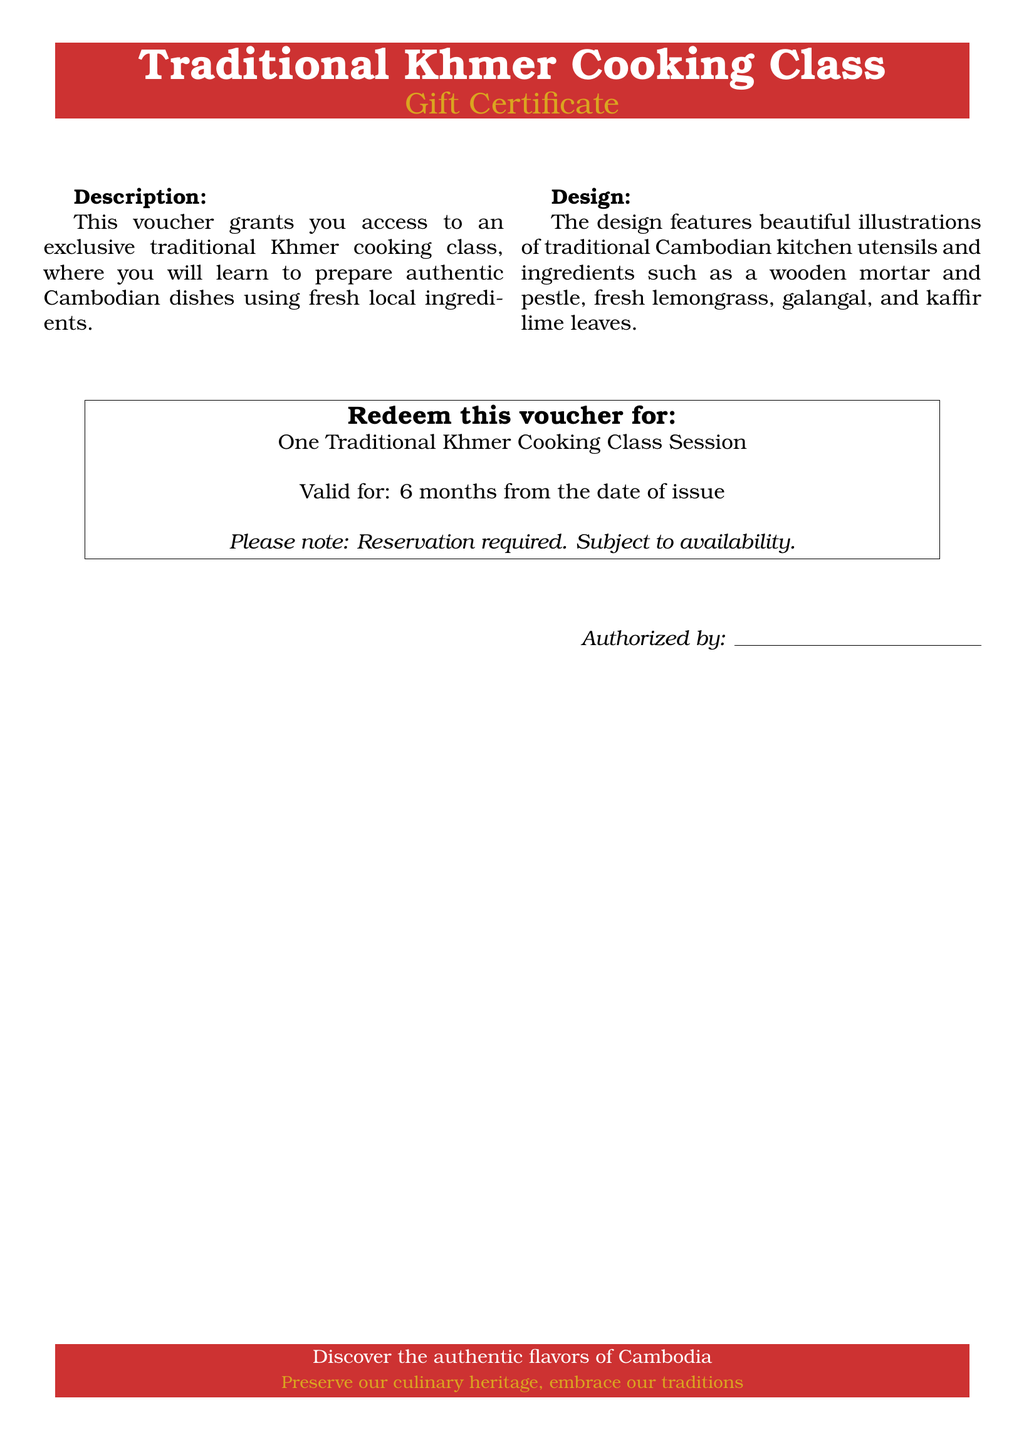What is the title of the voucher? The title is prominently displayed at the top of the voucher, which indicates the primary service being offered.
Answer: Traditional Khmer Cooking Class What is the validity period for the voucher? The validity period is stated in the section concerning the redemption of the voucher.
Answer: 6 months What must participants do to use the voucher? The document provides a requirement that must be fulfilled to redeem the voucher for the cooking class.
Answer: Reservation required What type of sessions does this voucher cover? The type of session is specified in the redemption section, indicating what the recipient will experience.
Answer: One Traditional Khmer Cooking Class Session What design elements are featured on the voucher? The design elements include illustrations mentioned in the design description, showcasing the cultural aspect of the voucher.
Answer: Traditional Cambodian kitchen utensils What does the voucher encourage participants to do? The phrase that captures the essence of what the voucher promotes can be found at the end of the document.
Answer: Preserve our culinary heritage What should coupon holders check before attending the class? The document mentions specific conditions that may affect attendance at the cooking class.
Answer: Subject to availability Who is authorized to issue the voucher? The section at the bottom of the voucher includes a space for identification of the authorizing party.
Answer: Authorized by: [signature space] 